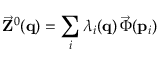<formula> <loc_0><loc_0><loc_500><loc_500>\vec { Z } ^ { 0 } ( { q } ) = \sum _ { i } \lambda _ { i } ( { q } ) \, \vec { \Phi } ( { p } _ { i } )</formula> 